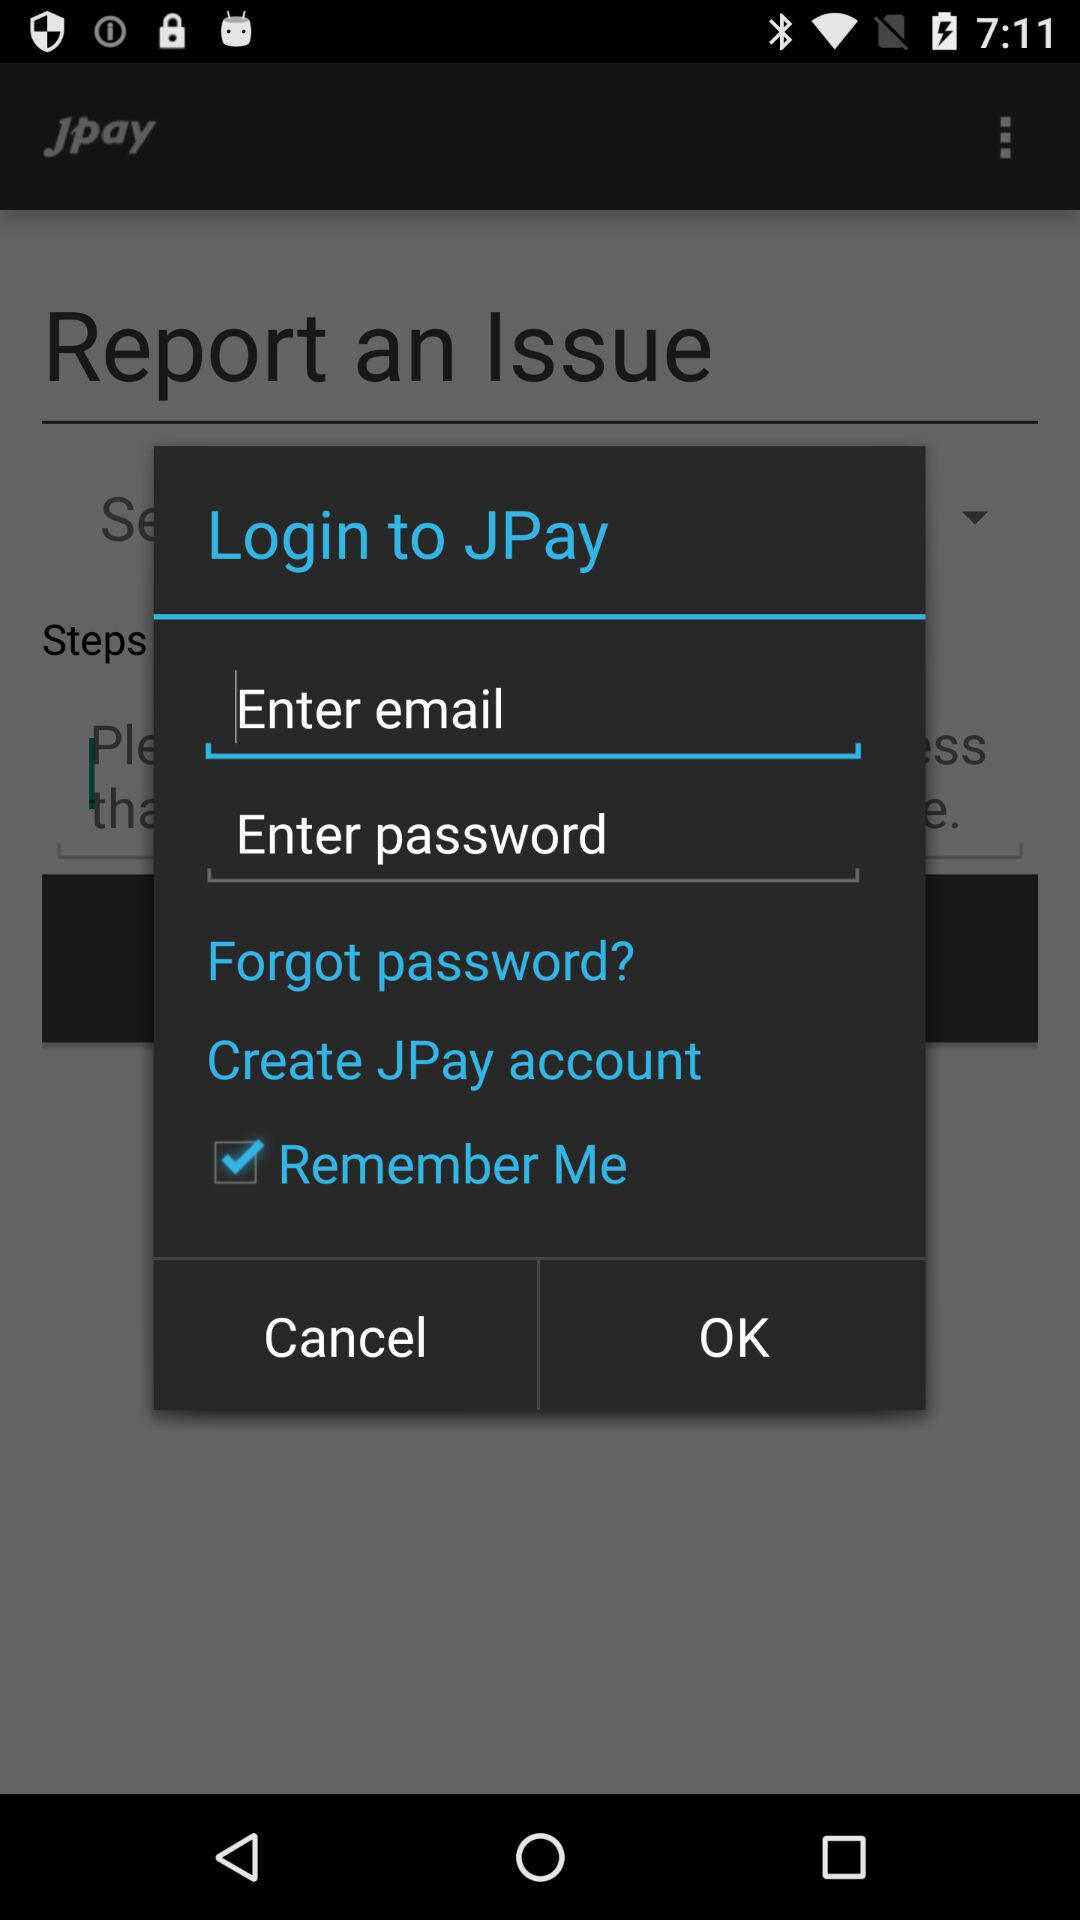What is the status of "Remember Me"? The status of "Remember Me" is "on". 